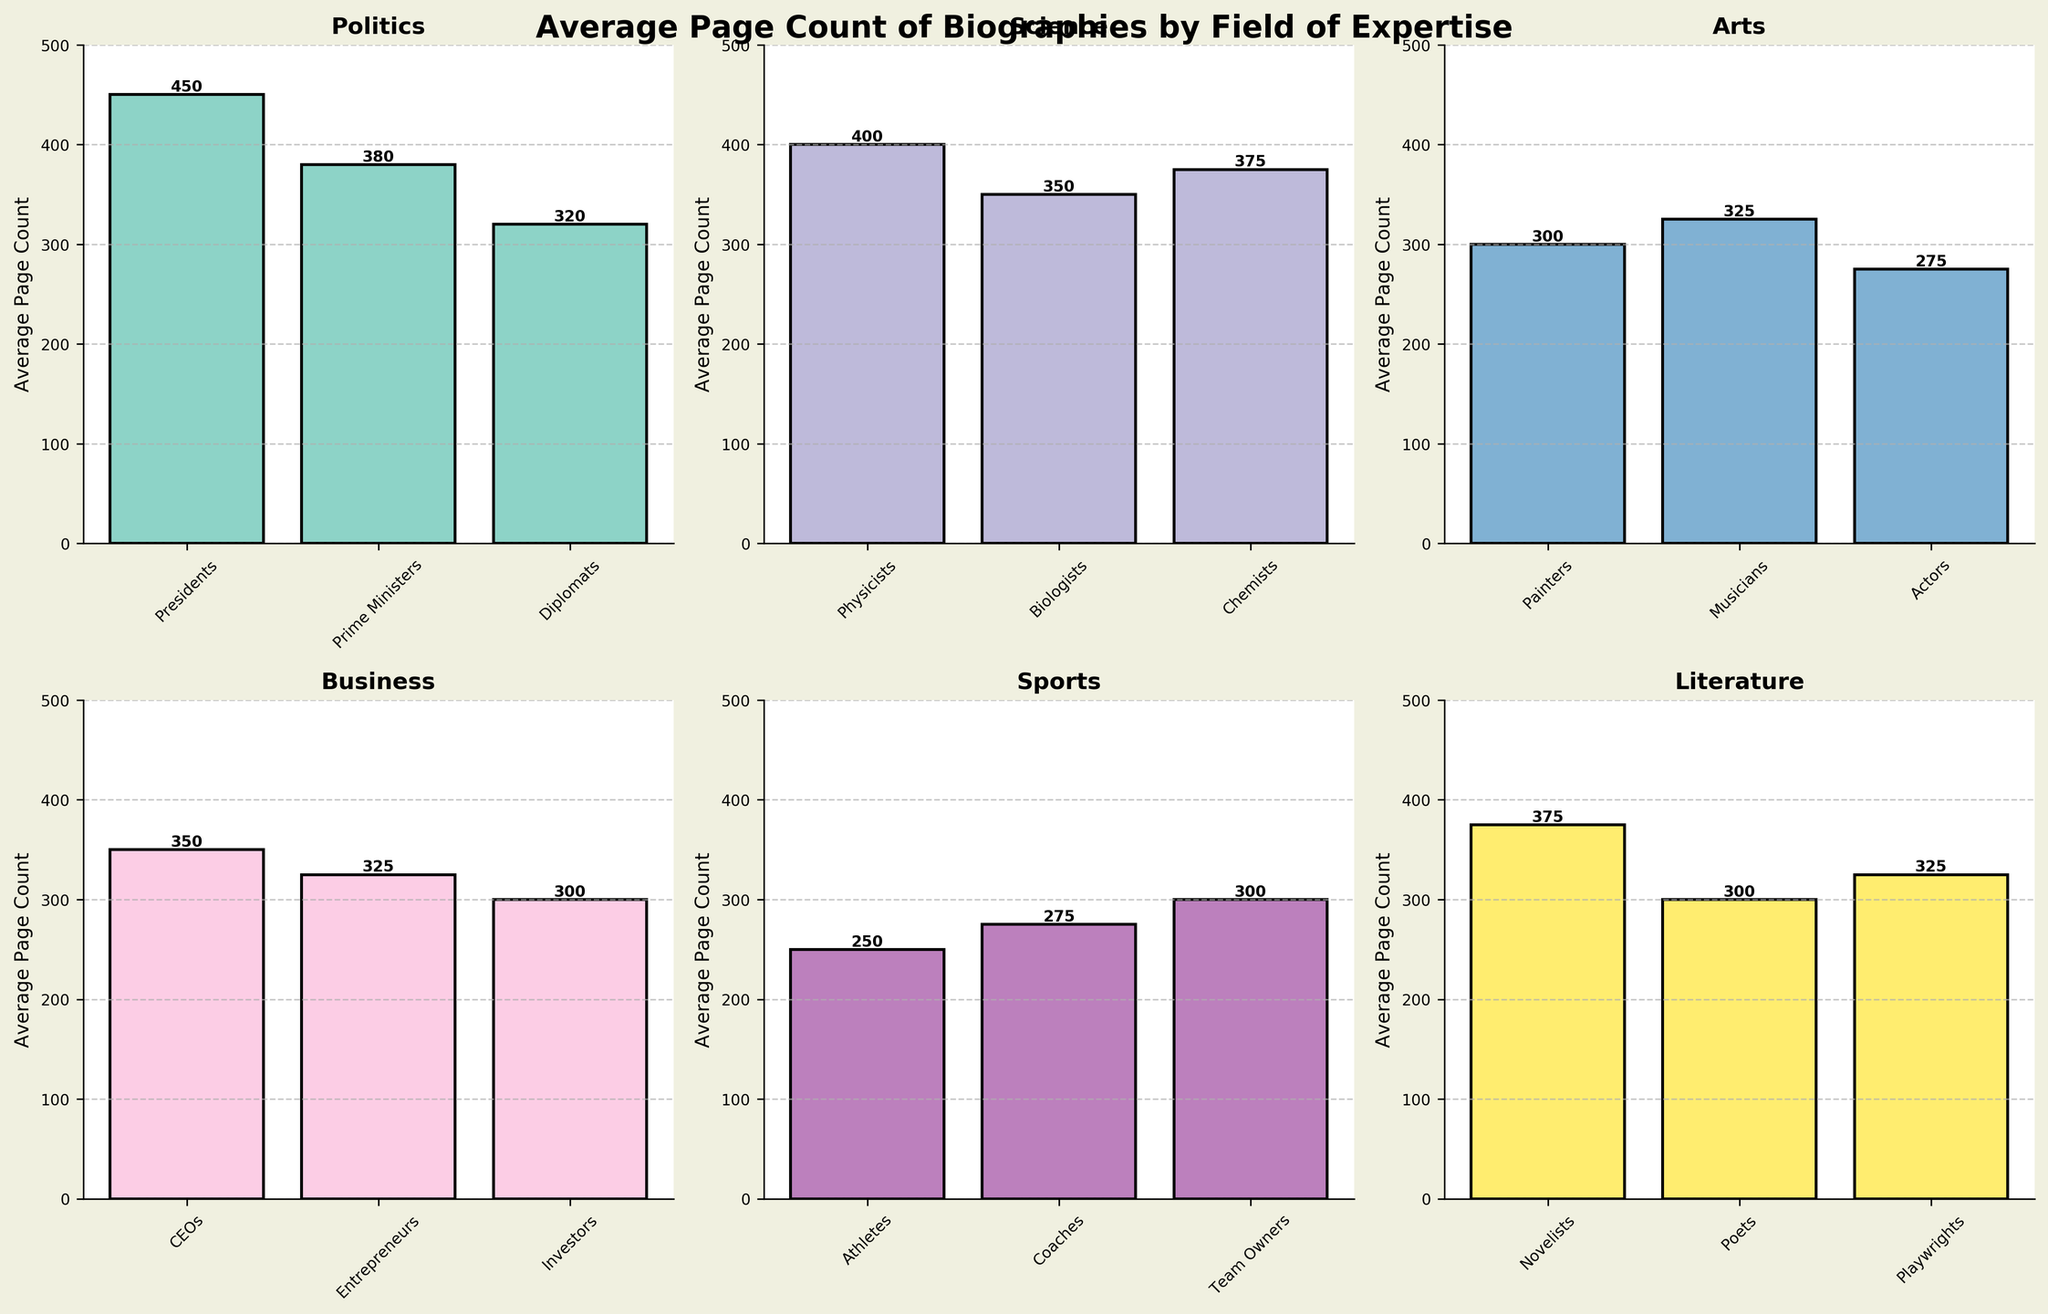What's the title of the figure? The title is located at the top center of the figure and reads: "Average Page Count of Biographies by Field of Expertise"
Answer: Average Page Count of Biographies by Field of Expertise What is the average page count for biographies of Presidents? In the "Politics" subplot, the bar for Presidents reaches 450, as labeled above the bar.
Answer: 450 Which field has the highest average page count for biographies, and what is it? Among all the fields, the "Politics" subplot shows the highest bar for Presidents with an average page count of 450.
Answer: Politics, 450 How does the average page count for Scientists compare across different specializations? In the "Science" subplot, Physicists' average page count is 400, Biologists have 350, and Chemists have 375. Hence, Physicists have the highest, followed by Chemists, then Biologists.
Answer: Physicists: 400, Biologists: 350, Chemists: 375 Is there any field where all subjects have the same average page count? Examining all subplots, no field has subjects with identical average page counts; each category has varying values.
Answer: No Which subject has the lowest average page count, and what is the value? In the "Sports" subplot, Athletes have the lowest average page count of 250, which is the lowest among all subjects.
Answer: Athletes, 250 Are there any fields where the difference between the highest and lowest average page counts is less than 50 pages? In the "Arts" subplot: the highest average (Musicians: 325) and lowest (Actors: 275) page counts differ by 50 pages. No other fields exhibit such a narrow range.
Answer: No What's the difference between the average page counts of CEOs and Entrepreneurs in the Business field? In the "Business" subplot, CEOs have an average of 350 pages and Entrepreneurs have 325 pages. The difference is 350 - 325 = 25.
Answer: 25 How does the average page count for Novelists compare to that for Playwrights in the Literature field? In the "Literature" subplot, Novelists have an average page count of 375 while Playwrights have 325, so Novelists' average page count is higher by 50 pages.
Answer: Novelists have 50 pages more than Playwrights Which field has the widest range of average page counts between its subjects, and what is that range? By comparing each field, the "Politics" subplot has Presidents with 450 and Diplomats with 320. The range is 450 - 320 = 130, which is the widest among all.
Answer: Politics, 130 